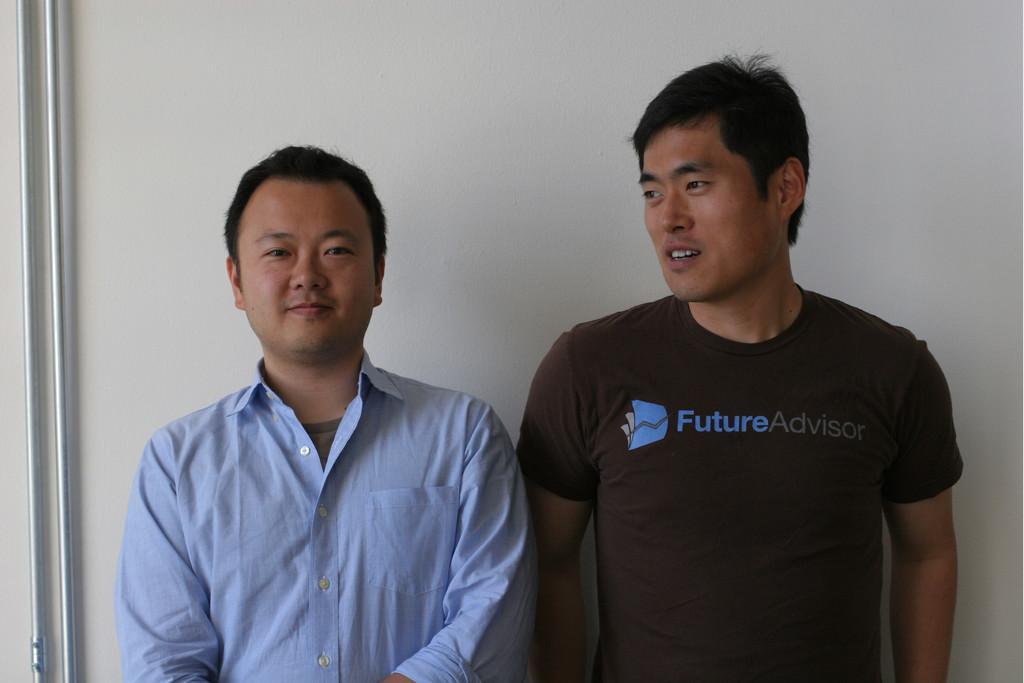Describe this image in one or two sentences. In this picture there are two persons standing and smiling. At the back there is a wall and there are pipes on the wall. 